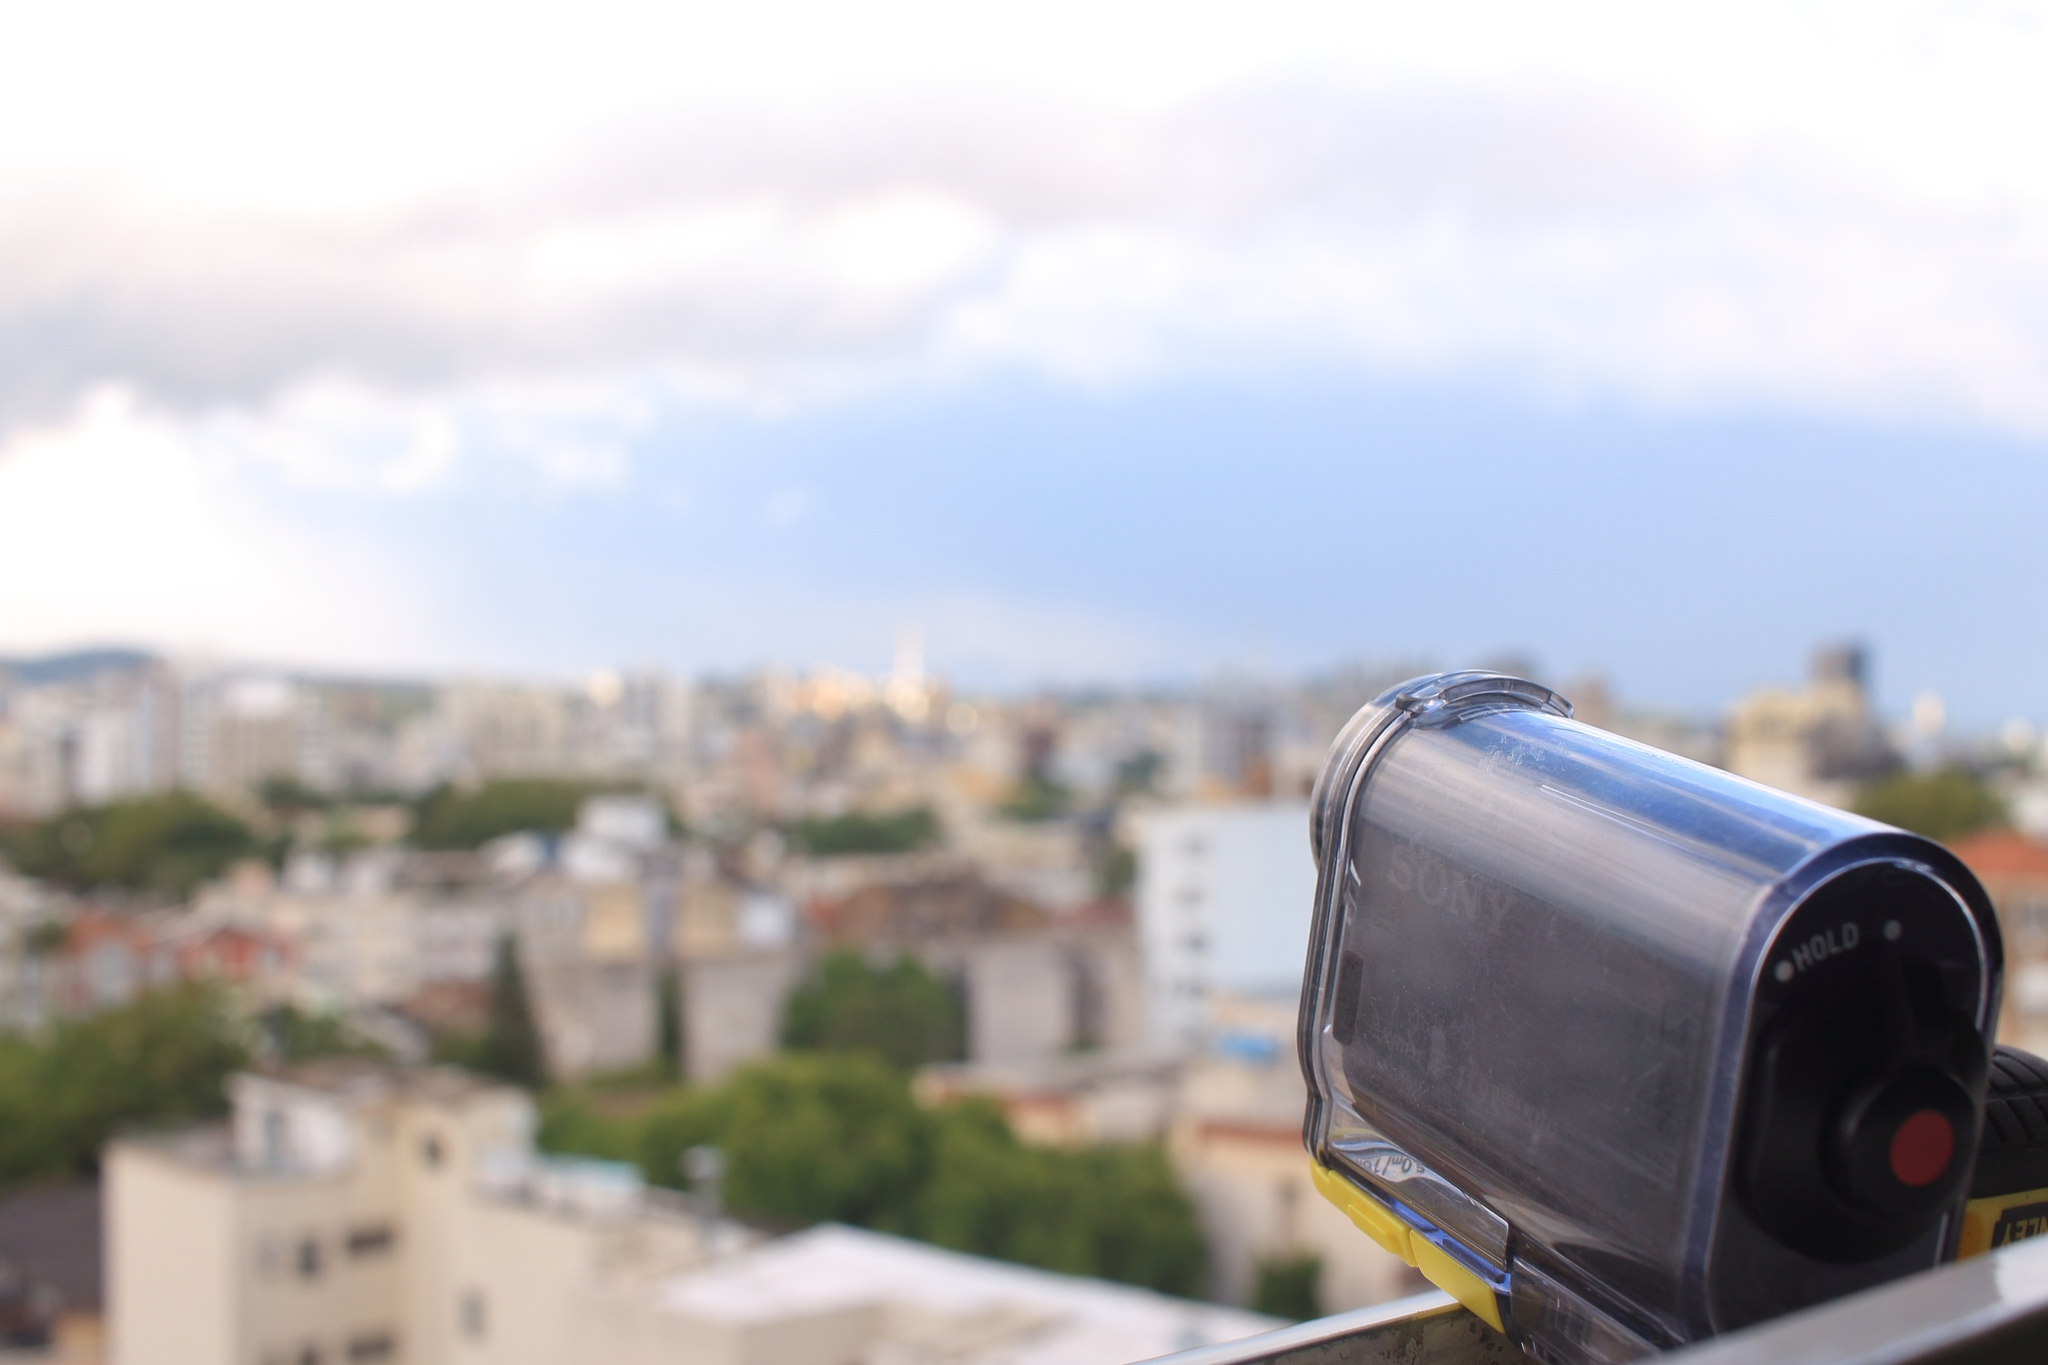What do you see happening in this image? In this image, a sleek and modern Sony camera, featuring a black and silver design, is mounted securely on a black tripod. The camera is prominently positioned in the foreground, its lens attentively aiming towards a vast, bustling cityscape in the background. This sprawling urban environment is characterized by an eclectic mix of buildings, differing in color, height, and architectural style, which together create a lively metropolitan panorama. The sky overhead is a serene shade of blue, decorated with fluffy, white clouds, indicative of a clear and pleasant day. The perspective offered by the image suggests it was taken from an elevated vantage point, providing a broad and immersive view of the city below, as if the viewer is sharing this elevated perspective alongside the camera. 